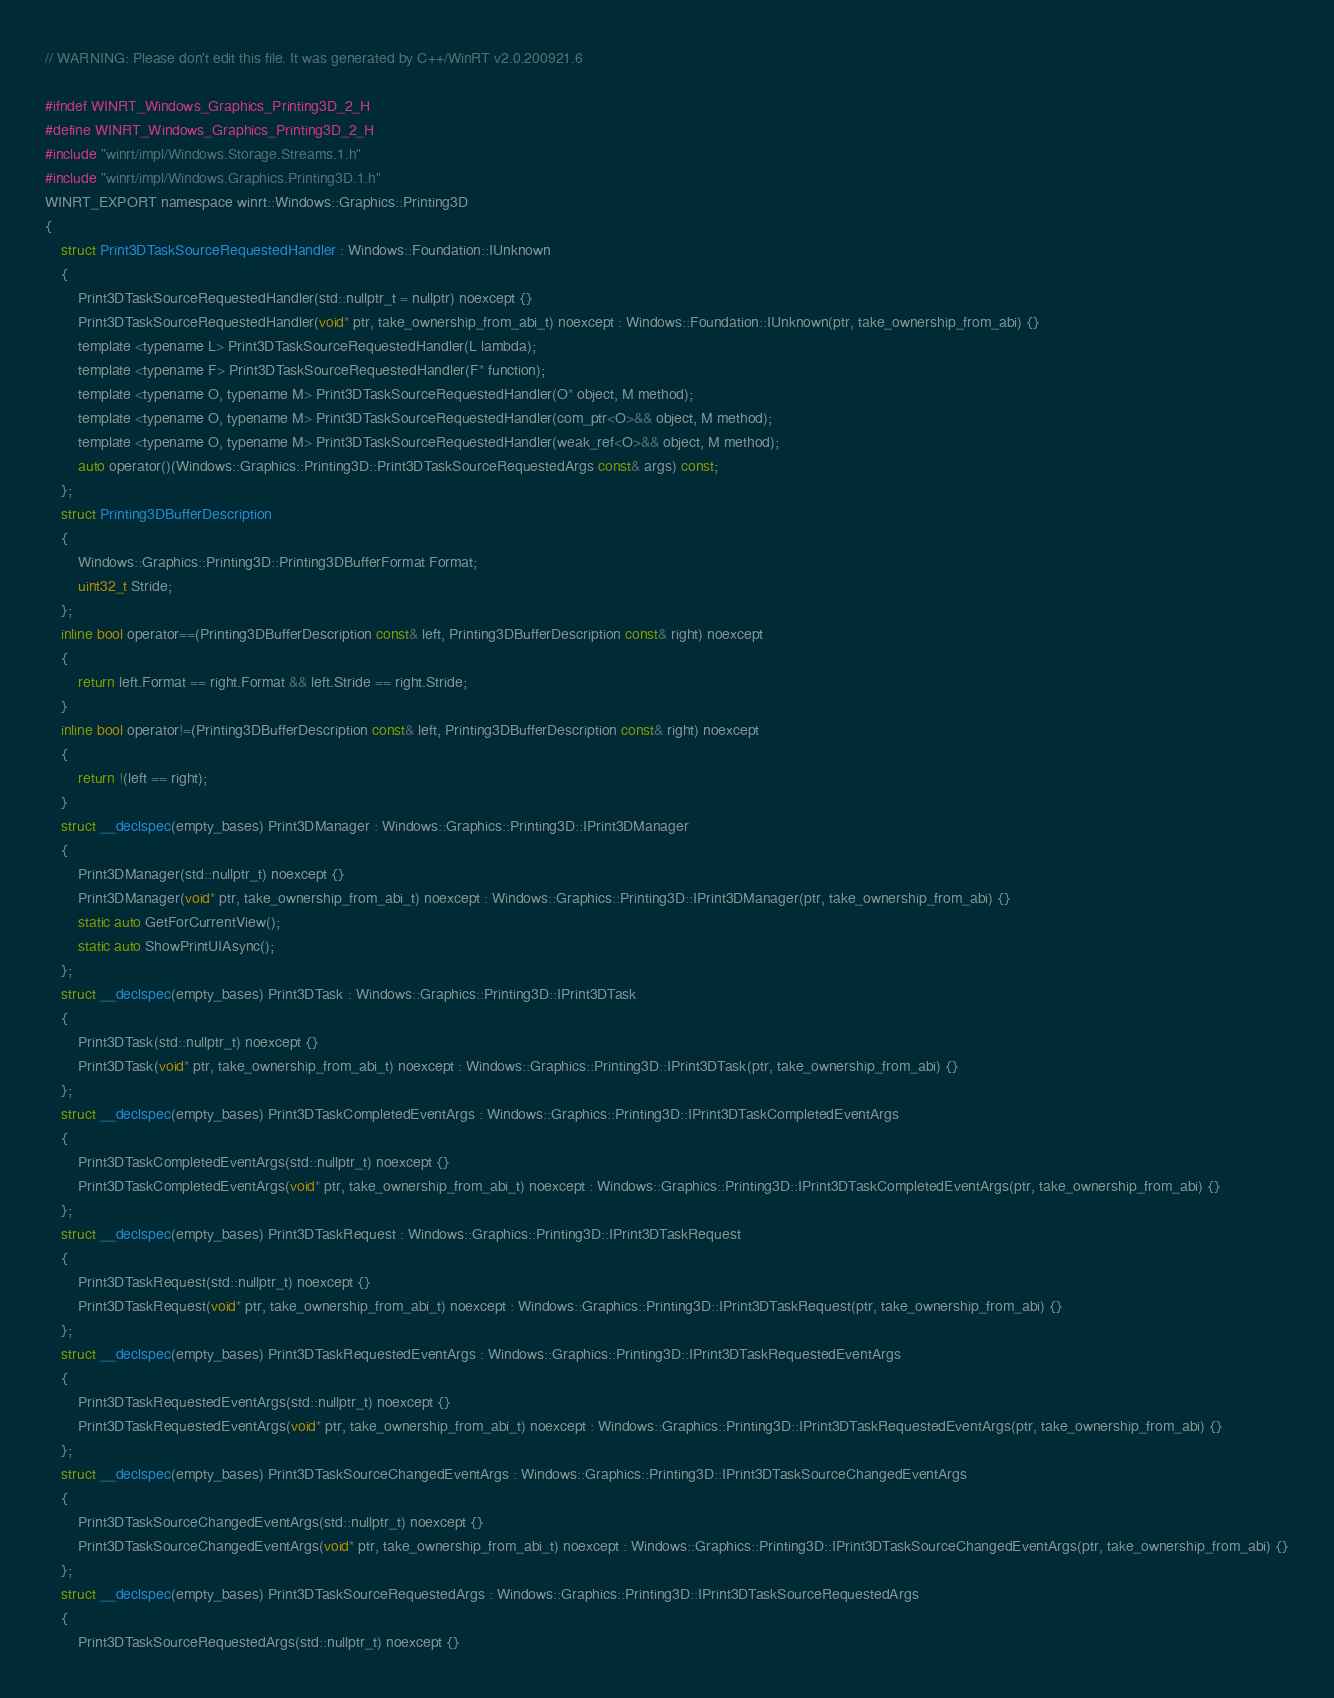<code> <loc_0><loc_0><loc_500><loc_500><_C_>// WARNING: Please don't edit this file. It was generated by C++/WinRT v2.0.200921.6

#ifndef WINRT_Windows_Graphics_Printing3D_2_H
#define WINRT_Windows_Graphics_Printing3D_2_H
#include "winrt/impl/Windows.Storage.Streams.1.h"
#include "winrt/impl/Windows.Graphics.Printing3D.1.h"
WINRT_EXPORT namespace winrt::Windows::Graphics::Printing3D
{
    struct Print3DTaskSourceRequestedHandler : Windows::Foundation::IUnknown
    {
        Print3DTaskSourceRequestedHandler(std::nullptr_t = nullptr) noexcept {}
        Print3DTaskSourceRequestedHandler(void* ptr, take_ownership_from_abi_t) noexcept : Windows::Foundation::IUnknown(ptr, take_ownership_from_abi) {}
        template <typename L> Print3DTaskSourceRequestedHandler(L lambda);
        template <typename F> Print3DTaskSourceRequestedHandler(F* function);
        template <typename O, typename M> Print3DTaskSourceRequestedHandler(O* object, M method);
        template <typename O, typename M> Print3DTaskSourceRequestedHandler(com_ptr<O>&& object, M method);
        template <typename O, typename M> Print3DTaskSourceRequestedHandler(weak_ref<O>&& object, M method);
        auto operator()(Windows::Graphics::Printing3D::Print3DTaskSourceRequestedArgs const& args) const;
    };
    struct Printing3DBufferDescription
    {
        Windows::Graphics::Printing3D::Printing3DBufferFormat Format;
        uint32_t Stride;
    };
    inline bool operator==(Printing3DBufferDescription const& left, Printing3DBufferDescription const& right) noexcept
    {
        return left.Format == right.Format && left.Stride == right.Stride;
    }
    inline bool operator!=(Printing3DBufferDescription const& left, Printing3DBufferDescription const& right) noexcept
    {
        return !(left == right);
    }
    struct __declspec(empty_bases) Print3DManager : Windows::Graphics::Printing3D::IPrint3DManager
    {
        Print3DManager(std::nullptr_t) noexcept {}
        Print3DManager(void* ptr, take_ownership_from_abi_t) noexcept : Windows::Graphics::Printing3D::IPrint3DManager(ptr, take_ownership_from_abi) {}
        static auto GetForCurrentView();
        static auto ShowPrintUIAsync();
    };
    struct __declspec(empty_bases) Print3DTask : Windows::Graphics::Printing3D::IPrint3DTask
    {
        Print3DTask(std::nullptr_t) noexcept {}
        Print3DTask(void* ptr, take_ownership_from_abi_t) noexcept : Windows::Graphics::Printing3D::IPrint3DTask(ptr, take_ownership_from_abi) {}
    };
    struct __declspec(empty_bases) Print3DTaskCompletedEventArgs : Windows::Graphics::Printing3D::IPrint3DTaskCompletedEventArgs
    {
        Print3DTaskCompletedEventArgs(std::nullptr_t) noexcept {}
        Print3DTaskCompletedEventArgs(void* ptr, take_ownership_from_abi_t) noexcept : Windows::Graphics::Printing3D::IPrint3DTaskCompletedEventArgs(ptr, take_ownership_from_abi) {}
    };
    struct __declspec(empty_bases) Print3DTaskRequest : Windows::Graphics::Printing3D::IPrint3DTaskRequest
    {
        Print3DTaskRequest(std::nullptr_t) noexcept {}
        Print3DTaskRequest(void* ptr, take_ownership_from_abi_t) noexcept : Windows::Graphics::Printing3D::IPrint3DTaskRequest(ptr, take_ownership_from_abi) {}
    };
    struct __declspec(empty_bases) Print3DTaskRequestedEventArgs : Windows::Graphics::Printing3D::IPrint3DTaskRequestedEventArgs
    {
        Print3DTaskRequestedEventArgs(std::nullptr_t) noexcept {}
        Print3DTaskRequestedEventArgs(void* ptr, take_ownership_from_abi_t) noexcept : Windows::Graphics::Printing3D::IPrint3DTaskRequestedEventArgs(ptr, take_ownership_from_abi) {}
    };
    struct __declspec(empty_bases) Print3DTaskSourceChangedEventArgs : Windows::Graphics::Printing3D::IPrint3DTaskSourceChangedEventArgs
    {
        Print3DTaskSourceChangedEventArgs(std::nullptr_t) noexcept {}
        Print3DTaskSourceChangedEventArgs(void* ptr, take_ownership_from_abi_t) noexcept : Windows::Graphics::Printing3D::IPrint3DTaskSourceChangedEventArgs(ptr, take_ownership_from_abi) {}
    };
    struct __declspec(empty_bases) Print3DTaskSourceRequestedArgs : Windows::Graphics::Printing3D::IPrint3DTaskSourceRequestedArgs
    {
        Print3DTaskSourceRequestedArgs(std::nullptr_t) noexcept {}</code> 